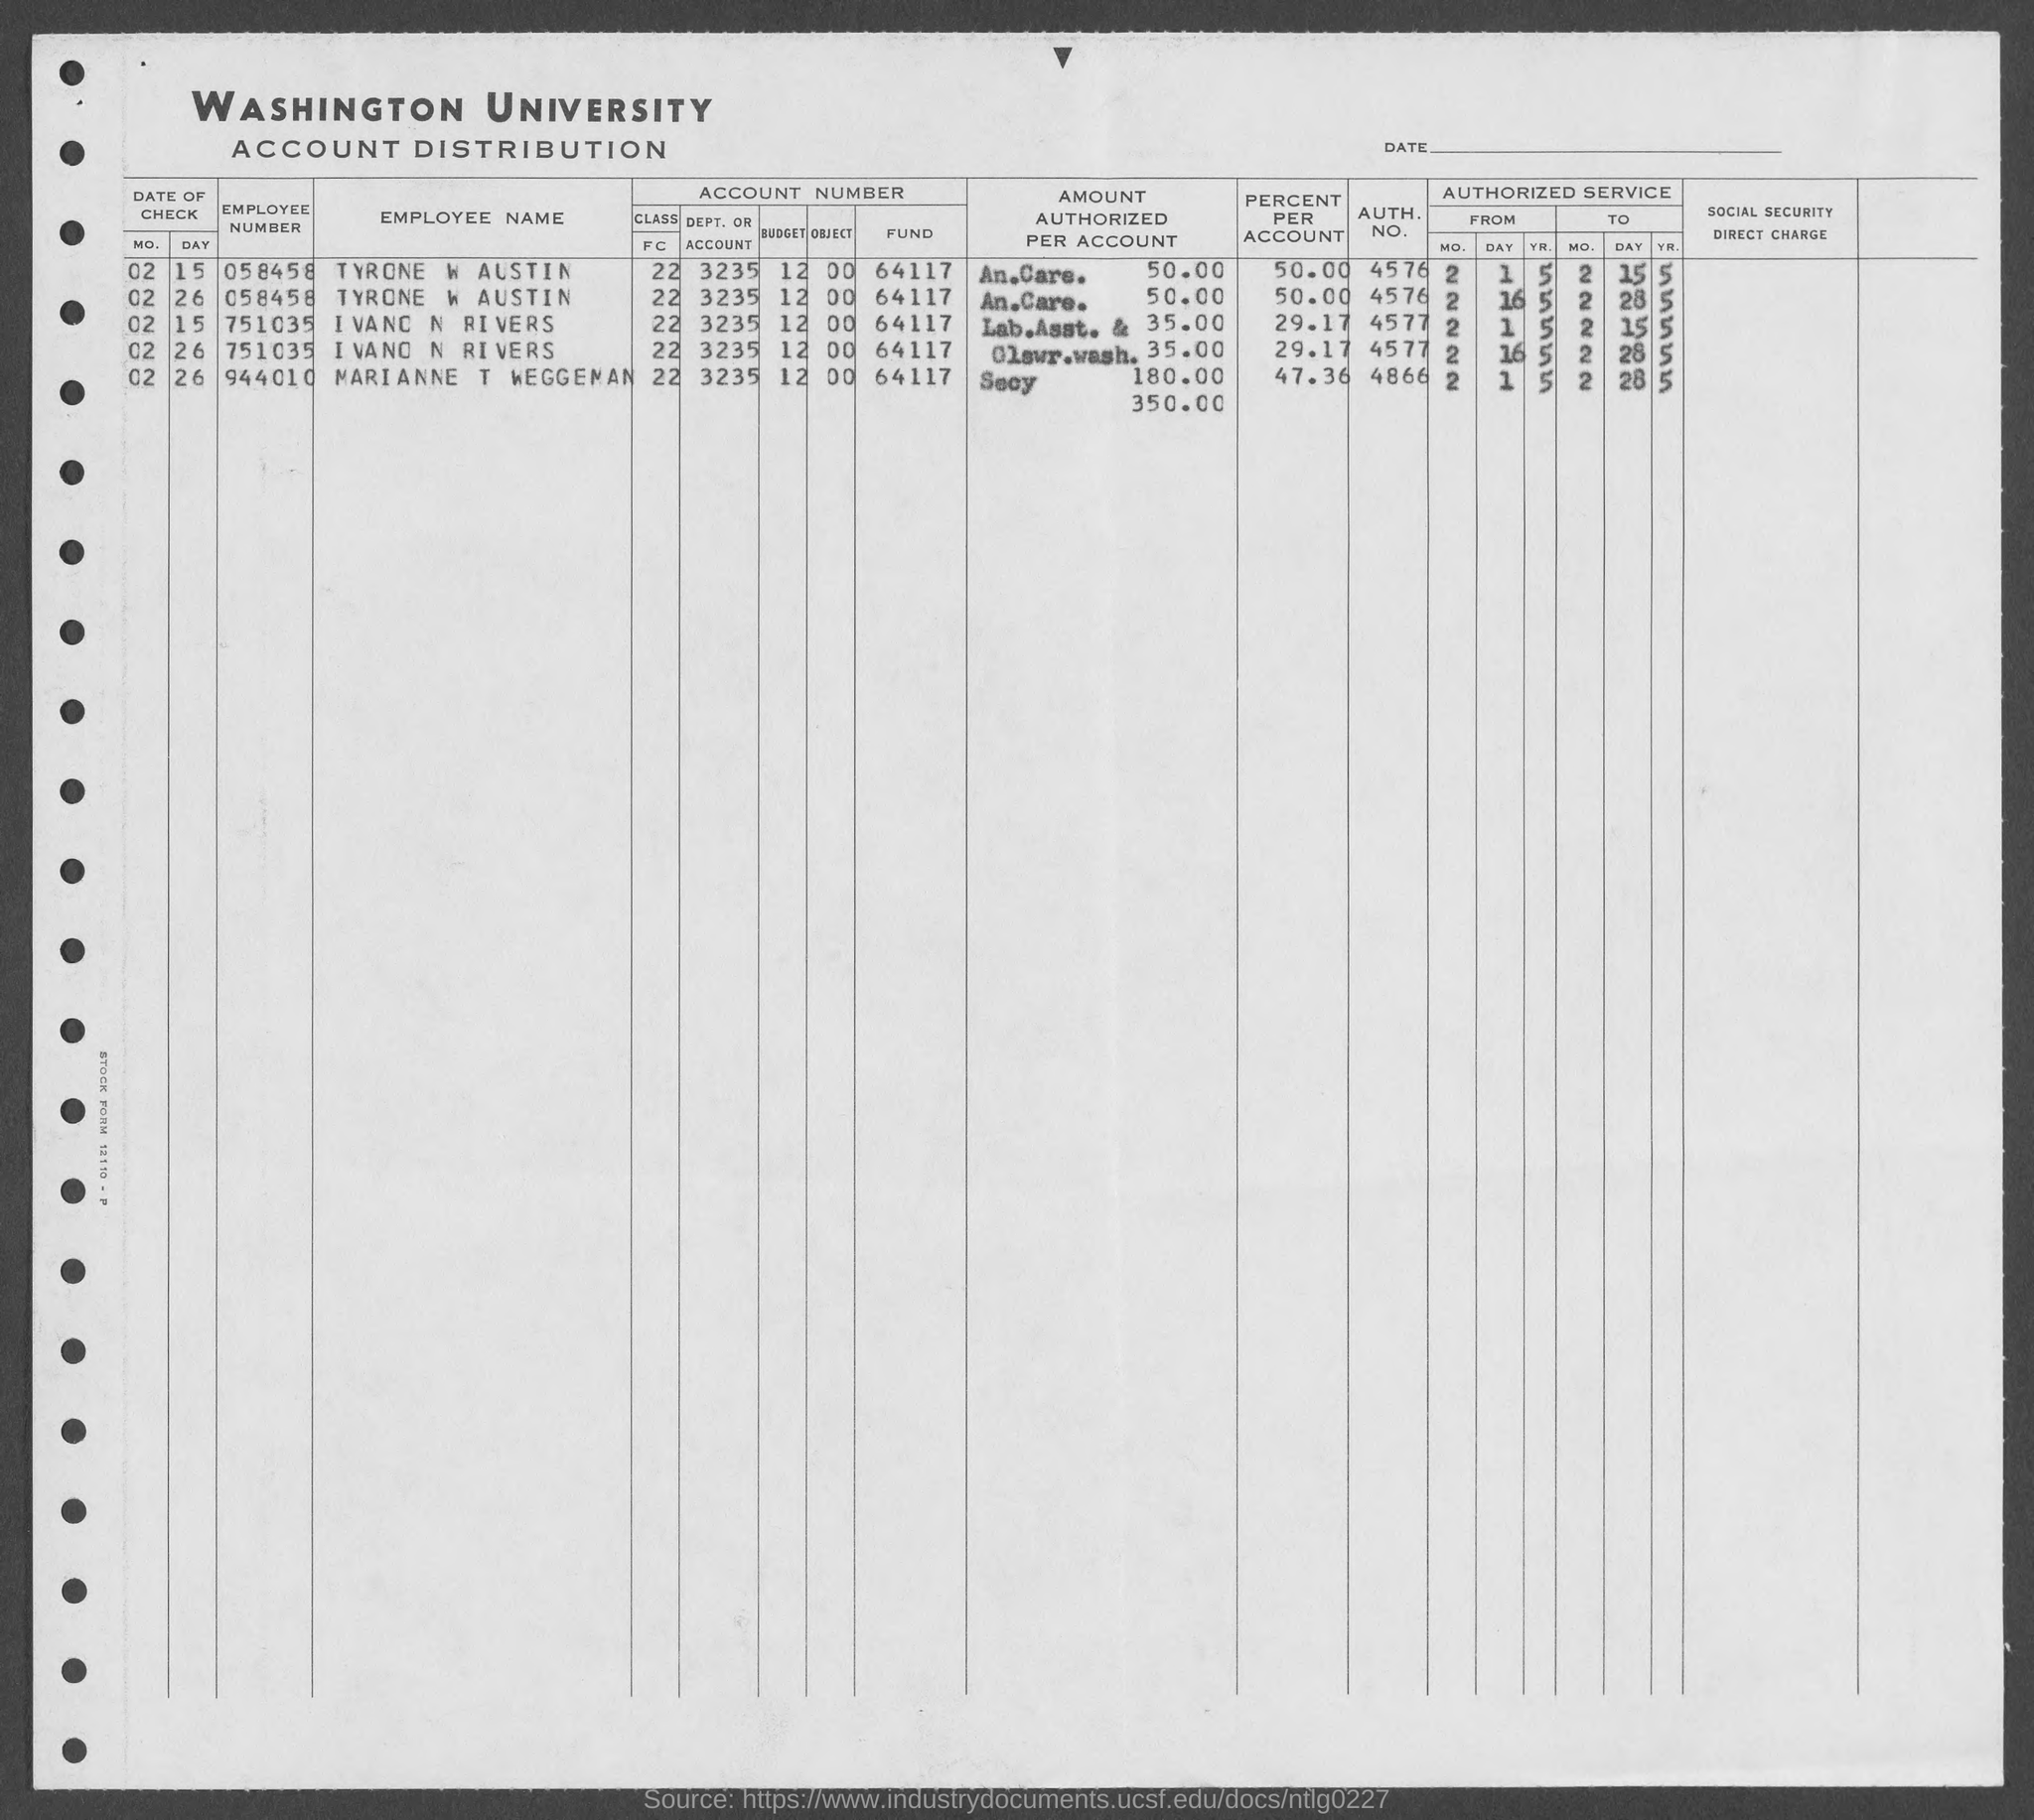What is the Employee Number of TYRONE W AUSTIN given in the document?
Keep it short and to the point. 058458. What is the Employee Number of IVANO N RIVERS given in the document?
Your response must be concise. 751035. What is the AUTH. NO. of TYRONE W AUSTIN given in the document?
Give a very brief answer. 4576. What is the AUTH. NO. of IVANO N RIVERS given in the document?
Provide a succinct answer. 4577. What is the percent per account of TYRONE W AUSTIN?
Give a very brief answer. 50.00. 